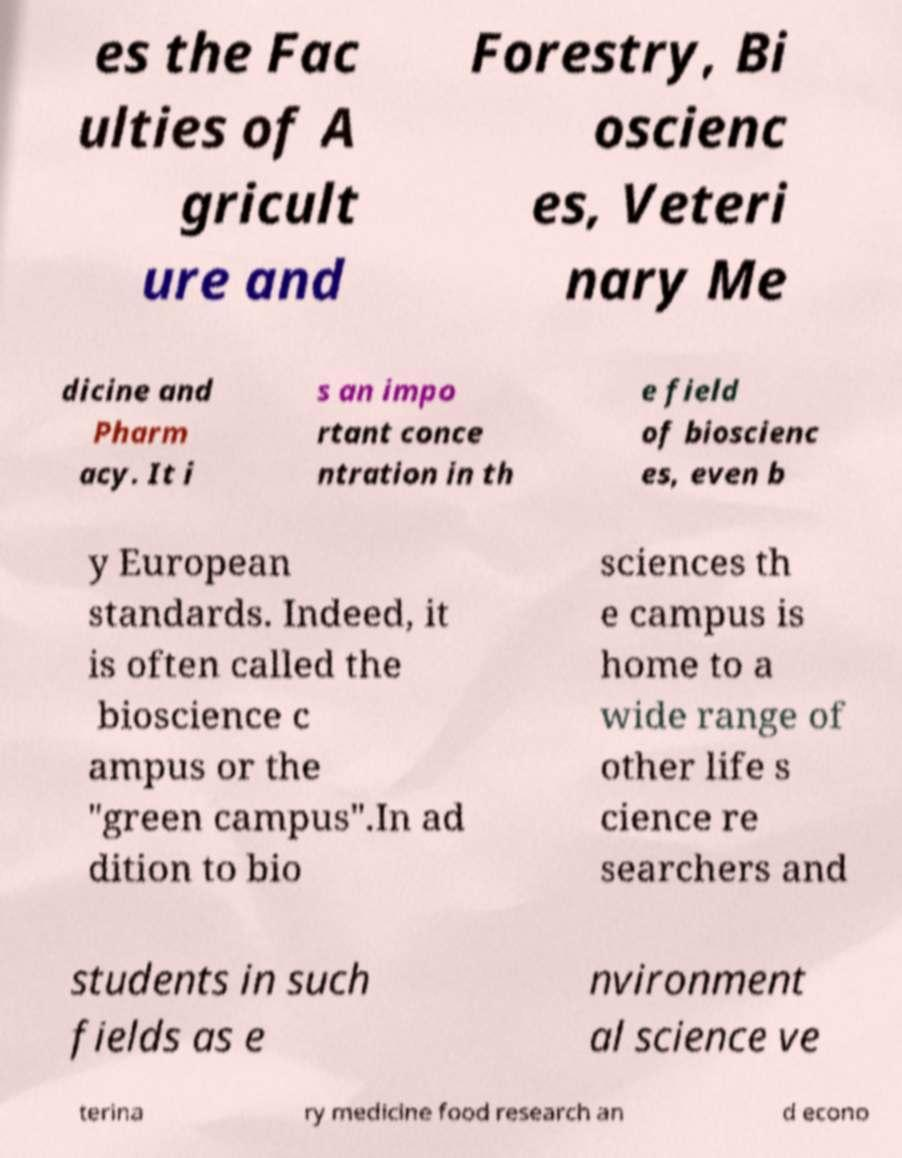Can you accurately transcribe the text from the provided image for me? es the Fac ulties of A gricult ure and Forestry, Bi oscienc es, Veteri nary Me dicine and Pharm acy. It i s an impo rtant conce ntration in th e field of bioscienc es, even b y European standards. Indeed, it is often called the bioscience c ampus or the "green campus".In ad dition to bio sciences th e campus is home to a wide range of other life s cience re searchers and students in such fields as e nvironment al science ve terina ry medicine food research an d econo 